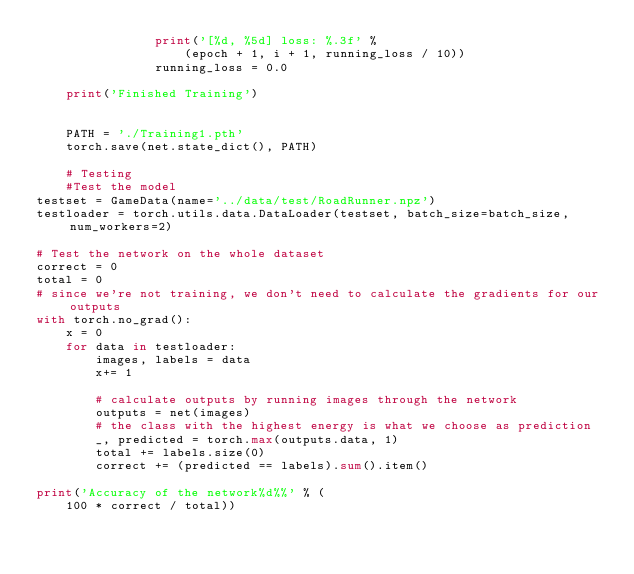Convert code to text. <code><loc_0><loc_0><loc_500><loc_500><_Python_>                print('[%d, %5d] loss: %.3f' %
                    (epoch + 1, i + 1, running_loss / 10))
                running_loss = 0.0

    print('Finished Training')

    
    PATH = './Training1.pth'
    torch.save(net.state_dict(), PATH)

    # Testing 
    #Test the model
testset = GameData(name='../data/test/RoadRunner.npz')
testloader = torch.utils.data.DataLoader(testset, batch_size=batch_size,num_workers=2)

# Test the network on the whole dataset
correct = 0
total = 0
# since we're not training, we don't need to calculate the gradients for our outputs
with torch.no_grad():
    x = 0
    for data in testloader:
        images, labels = data
        x+= 1

        # calculate outputs by running images through the network
        outputs = net(images)
        # the class with the highest energy is what we choose as prediction
        _, predicted = torch.max(outputs.data, 1)
        total += labels.size(0)
        correct += (predicted == labels).sum().item()

print('Accuracy of the network%d%%' % (
    100 * correct / total))</code> 